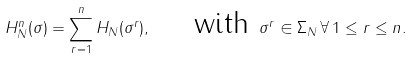<formula> <loc_0><loc_0><loc_500><loc_500>H _ { N } ^ { n } ( \sigma ) = \sum _ { r = 1 } ^ { n } H _ { N } ( \sigma ^ { r } ) , \quad \text { with } \sigma ^ { r } \in \Sigma _ { N } \, \forall \, 1 \leq r \leq n .</formula> 